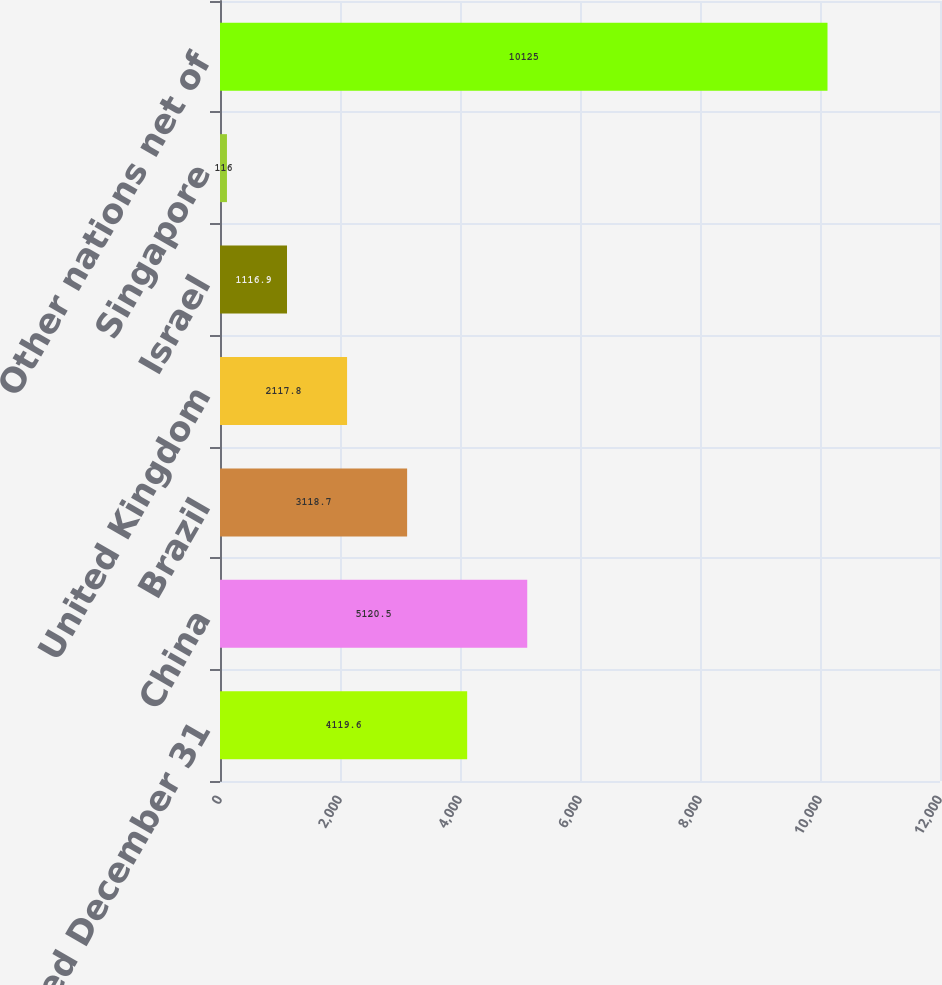Convert chart to OTSL. <chart><loc_0><loc_0><loc_500><loc_500><bar_chart><fcel>Years Ended December 31<fcel>China<fcel>Brazil<fcel>United Kingdom<fcel>Israel<fcel>Singapore<fcel>Other nations net of<nl><fcel>4119.6<fcel>5120.5<fcel>3118.7<fcel>2117.8<fcel>1116.9<fcel>116<fcel>10125<nl></chart> 